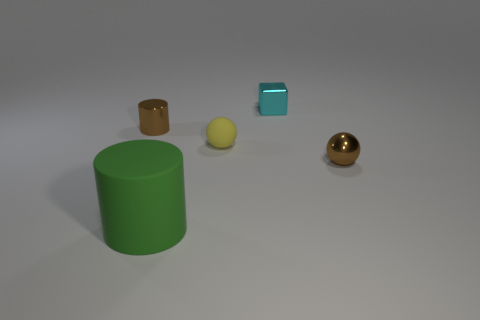Add 4 green cylinders. How many objects exist? 9 Subtract all blocks. How many objects are left? 4 Subtract all large gray metallic objects. Subtract all small blocks. How many objects are left? 4 Add 2 metal things. How many metal things are left? 5 Add 2 big purple metallic balls. How many big purple metallic balls exist? 2 Subtract 1 green cylinders. How many objects are left? 4 